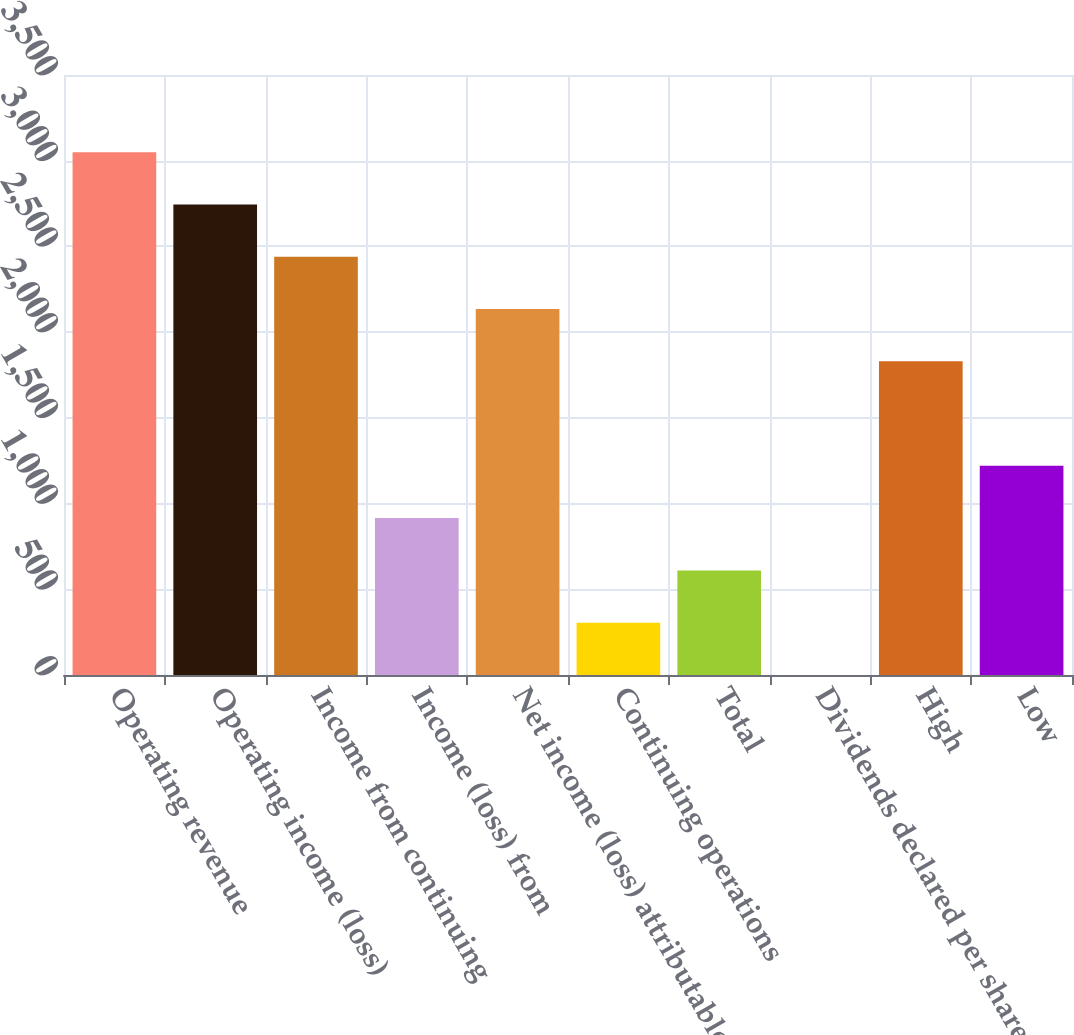Convert chart to OTSL. <chart><loc_0><loc_0><loc_500><loc_500><bar_chart><fcel>Operating revenue<fcel>Operating income (loss)<fcel>Income from continuing<fcel>Income (loss) from<fcel>Net income (loss) attributable<fcel>Continuing operations<fcel>Total<fcel>Dividends declared per share<fcel>High<fcel>Low<nl><fcel>3050.02<fcel>2745.05<fcel>2440.08<fcel>915.23<fcel>2135.11<fcel>305.29<fcel>610.26<fcel>0.32<fcel>1830.14<fcel>1220.2<nl></chart> 